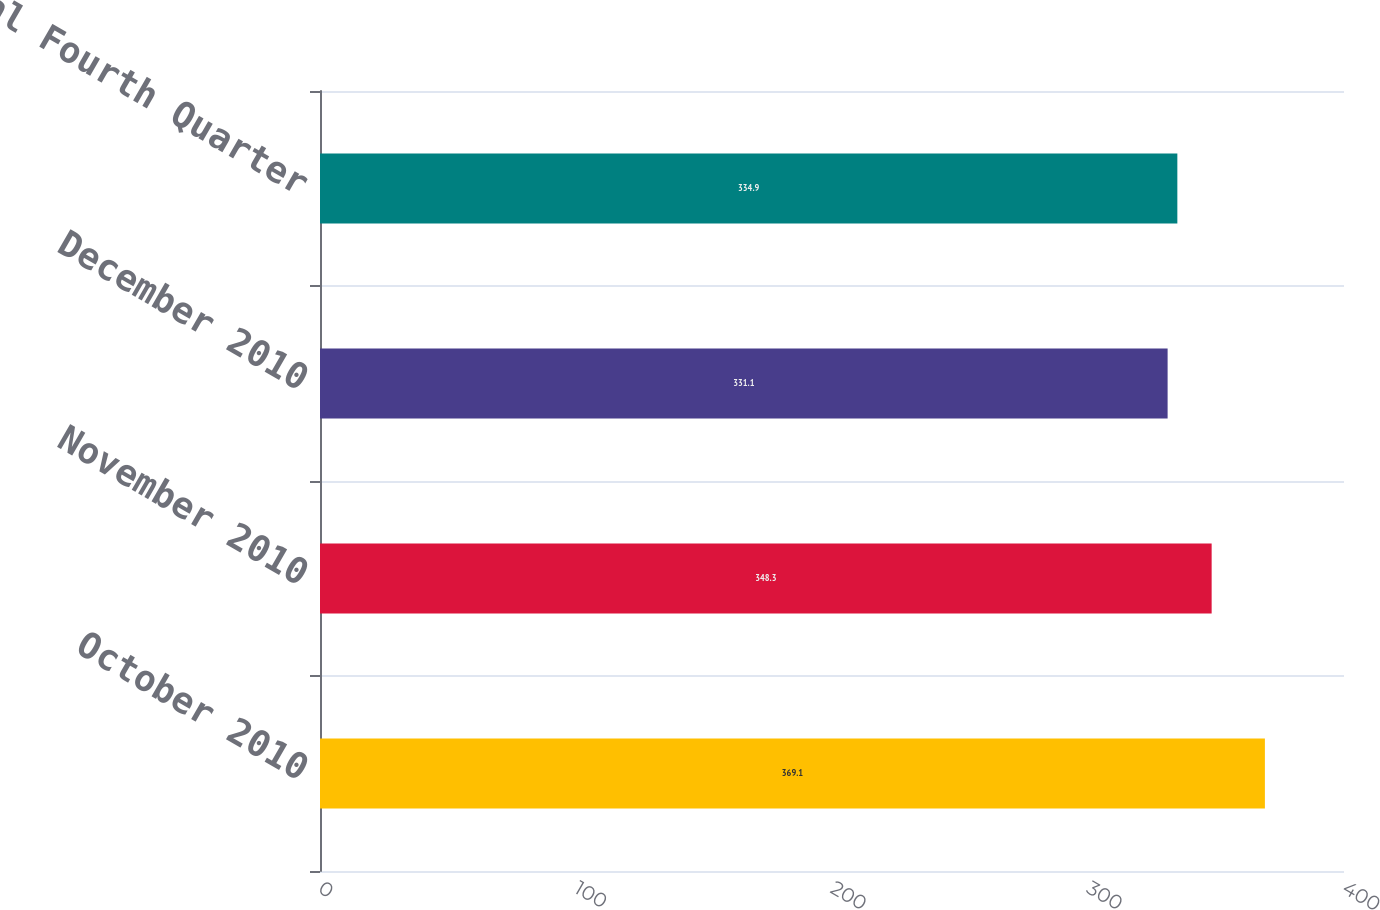<chart> <loc_0><loc_0><loc_500><loc_500><bar_chart><fcel>October 2010<fcel>November 2010<fcel>December 2010<fcel>Total Fourth Quarter<nl><fcel>369.1<fcel>348.3<fcel>331.1<fcel>334.9<nl></chart> 